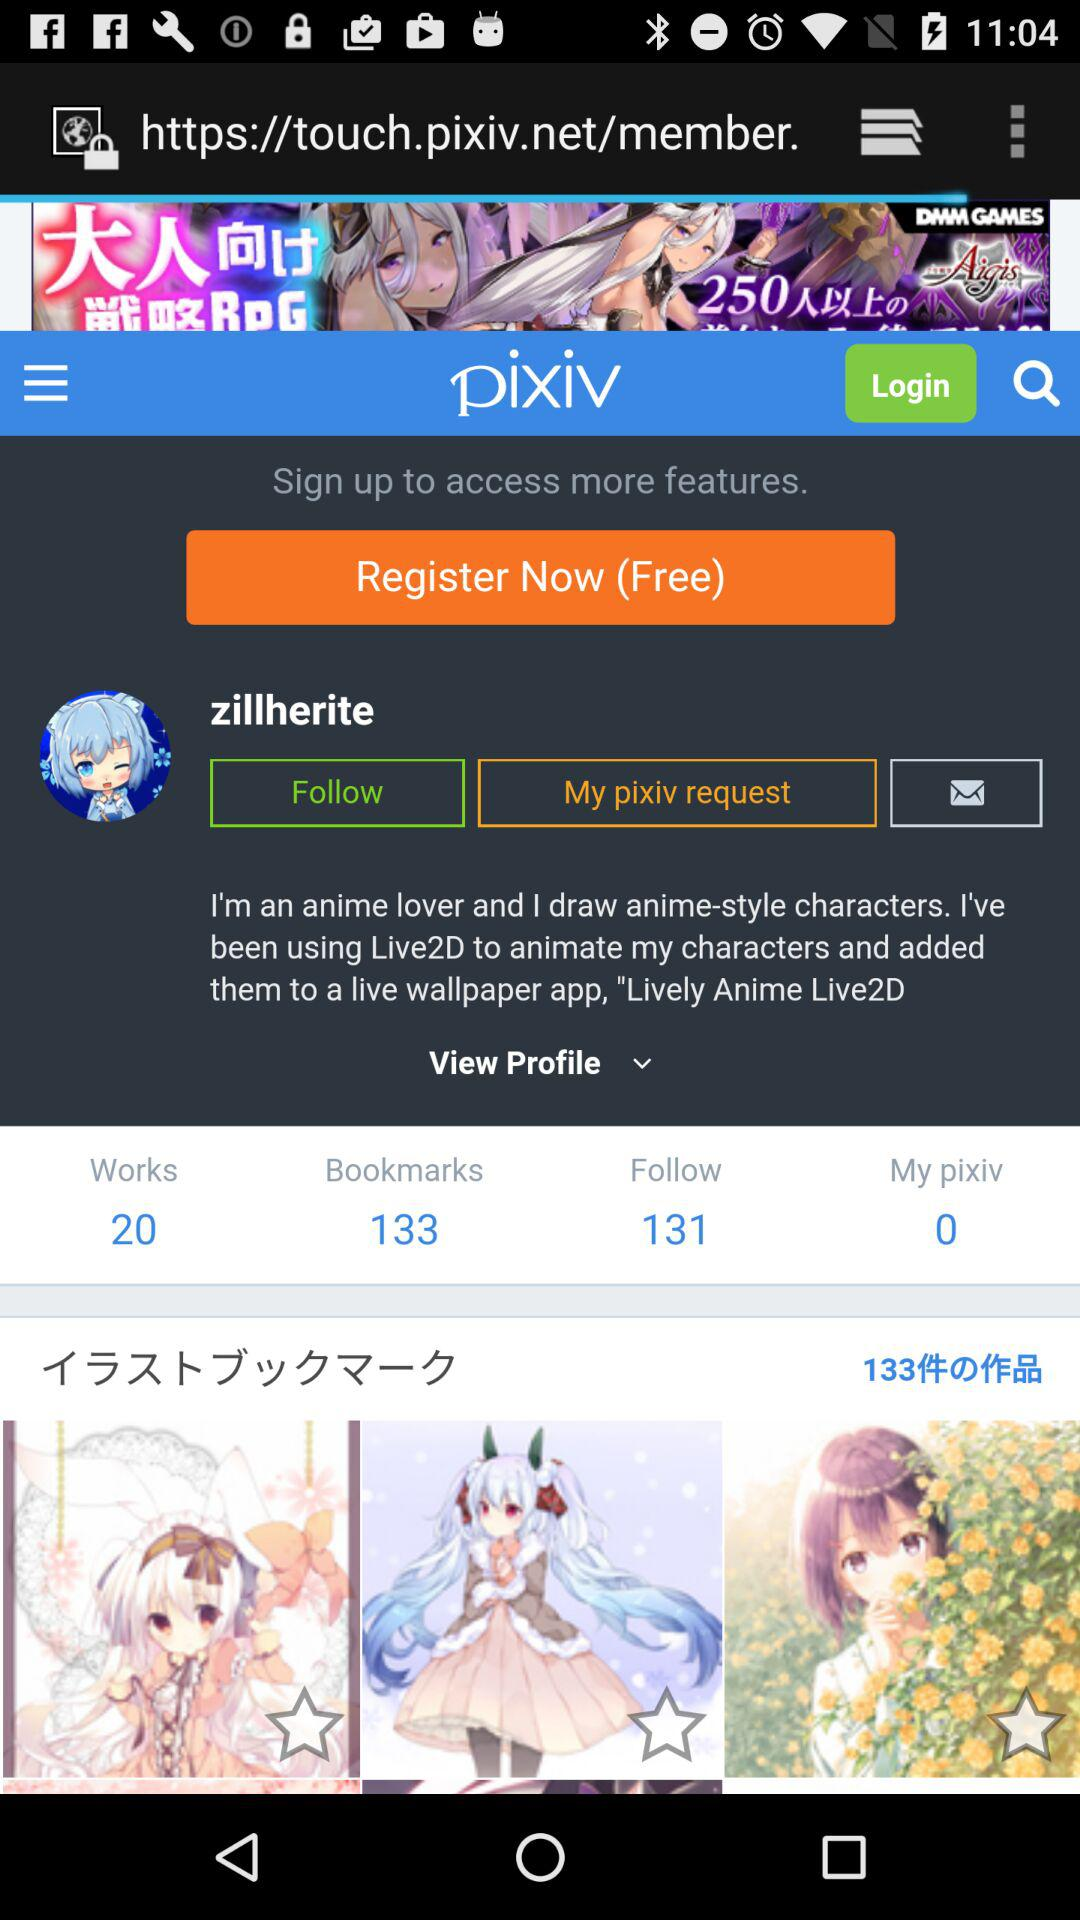How many followers are there? There are 131 followers. 